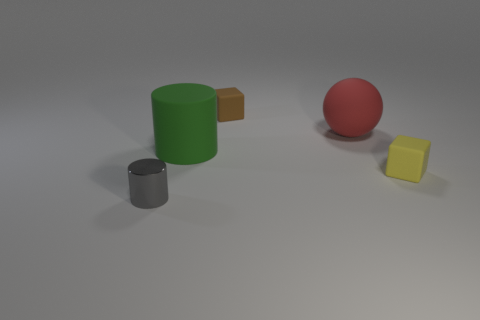Subtract 1 balls. How many balls are left? 0 Add 4 large cylinders. How many objects exist? 9 Subtract all cyan blocks. How many green cylinders are left? 1 Subtract all big rubber things. Subtract all big things. How many objects are left? 1 Add 2 gray things. How many gray things are left? 3 Add 2 large gray objects. How many large gray objects exist? 2 Subtract all gray cylinders. How many cylinders are left? 1 Subtract 0 blue balls. How many objects are left? 5 Subtract all blocks. How many objects are left? 3 Subtract all yellow cylinders. Subtract all purple blocks. How many cylinders are left? 2 